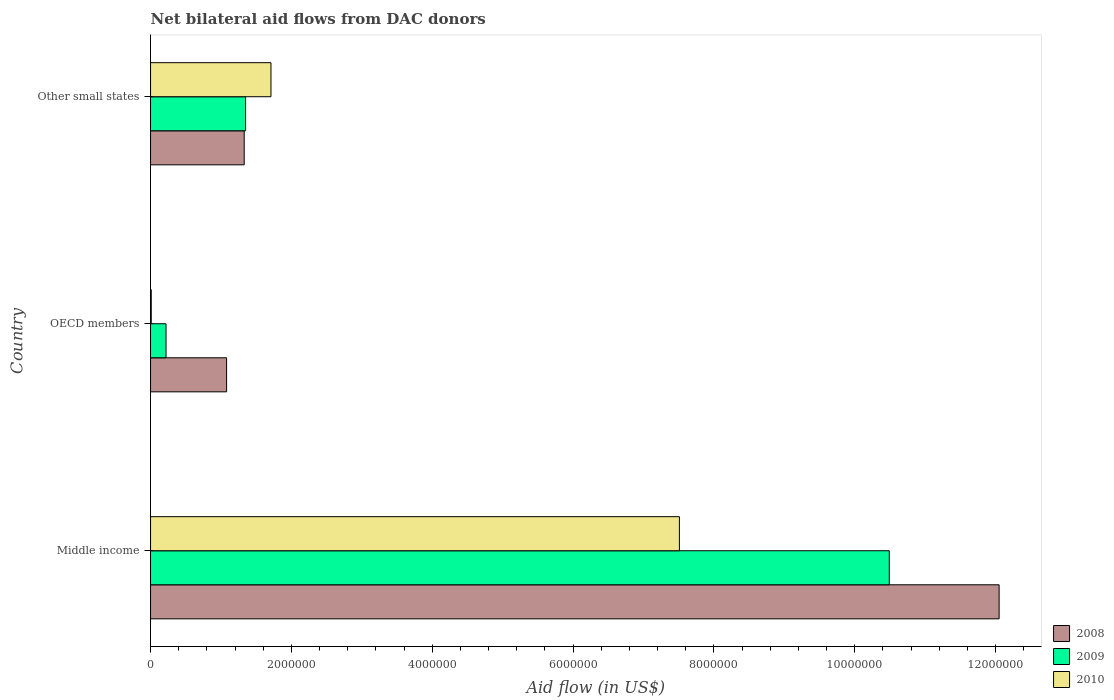How many groups of bars are there?
Provide a succinct answer. 3. Are the number of bars per tick equal to the number of legend labels?
Your response must be concise. Yes. Are the number of bars on each tick of the Y-axis equal?
Offer a terse response. Yes. How many bars are there on the 1st tick from the top?
Your response must be concise. 3. How many bars are there on the 2nd tick from the bottom?
Give a very brief answer. 3. What is the label of the 1st group of bars from the top?
Your response must be concise. Other small states. What is the net bilateral aid flow in 2010 in Other small states?
Your answer should be very brief. 1.71e+06. Across all countries, what is the maximum net bilateral aid flow in 2008?
Give a very brief answer. 1.20e+07. Across all countries, what is the minimum net bilateral aid flow in 2010?
Your response must be concise. 10000. In which country was the net bilateral aid flow in 2008 maximum?
Ensure brevity in your answer.  Middle income. In which country was the net bilateral aid flow in 2008 minimum?
Provide a succinct answer. OECD members. What is the total net bilateral aid flow in 2008 in the graph?
Ensure brevity in your answer.  1.45e+07. What is the difference between the net bilateral aid flow in 2008 in Middle income and that in Other small states?
Provide a short and direct response. 1.07e+07. What is the difference between the net bilateral aid flow in 2008 in Middle income and the net bilateral aid flow in 2010 in Other small states?
Offer a very short reply. 1.03e+07. What is the average net bilateral aid flow in 2009 per country?
Provide a succinct answer. 4.02e+06. What is the difference between the net bilateral aid flow in 2010 and net bilateral aid flow in 2009 in Middle income?
Provide a short and direct response. -2.98e+06. In how many countries, is the net bilateral aid flow in 2008 greater than 3200000 US$?
Offer a very short reply. 1. What is the ratio of the net bilateral aid flow in 2009 in Middle income to that in Other small states?
Offer a very short reply. 7.77. What is the difference between the highest and the second highest net bilateral aid flow in 2009?
Keep it short and to the point. 9.14e+06. What is the difference between the highest and the lowest net bilateral aid flow in 2010?
Offer a terse response. 7.50e+06. In how many countries, is the net bilateral aid flow in 2008 greater than the average net bilateral aid flow in 2008 taken over all countries?
Your response must be concise. 1. Is the sum of the net bilateral aid flow in 2009 in Middle income and OECD members greater than the maximum net bilateral aid flow in 2010 across all countries?
Your answer should be very brief. Yes. Is it the case that in every country, the sum of the net bilateral aid flow in 2010 and net bilateral aid flow in 2009 is greater than the net bilateral aid flow in 2008?
Keep it short and to the point. No. Are all the bars in the graph horizontal?
Give a very brief answer. Yes. How many countries are there in the graph?
Provide a succinct answer. 3. Are the values on the major ticks of X-axis written in scientific E-notation?
Offer a very short reply. No. Does the graph contain any zero values?
Offer a terse response. No. Where does the legend appear in the graph?
Offer a very short reply. Bottom right. What is the title of the graph?
Offer a terse response. Net bilateral aid flows from DAC donors. What is the label or title of the X-axis?
Your answer should be compact. Aid flow (in US$). What is the Aid flow (in US$) in 2008 in Middle income?
Keep it short and to the point. 1.20e+07. What is the Aid flow (in US$) of 2009 in Middle income?
Your answer should be very brief. 1.05e+07. What is the Aid flow (in US$) of 2010 in Middle income?
Provide a short and direct response. 7.51e+06. What is the Aid flow (in US$) of 2008 in OECD members?
Make the answer very short. 1.08e+06. What is the Aid flow (in US$) in 2008 in Other small states?
Your response must be concise. 1.33e+06. What is the Aid flow (in US$) in 2009 in Other small states?
Offer a terse response. 1.35e+06. What is the Aid flow (in US$) in 2010 in Other small states?
Your response must be concise. 1.71e+06. Across all countries, what is the maximum Aid flow (in US$) of 2008?
Provide a short and direct response. 1.20e+07. Across all countries, what is the maximum Aid flow (in US$) of 2009?
Your answer should be compact. 1.05e+07. Across all countries, what is the maximum Aid flow (in US$) in 2010?
Make the answer very short. 7.51e+06. Across all countries, what is the minimum Aid flow (in US$) of 2008?
Offer a terse response. 1.08e+06. Across all countries, what is the minimum Aid flow (in US$) of 2009?
Offer a very short reply. 2.20e+05. What is the total Aid flow (in US$) in 2008 in the graph?
Offer a very short reply. 1.45e+07. What is the total Aid flow (in US$) of 2009 in the graph?
Offer a very short reply. 1.21e+07. What is the total Aid flow (in US$) in 2010 in the graph?
Ensure brevity in your answer.  9.23e+06. What is the difference between the Aid flow (in US$) of 2008 in Middle income and that in OECD members?
Keep it short and to the point. 1.10e+07. What is the difference between the Aid flow (in US$) in 2009 in Middle income and that in OECD members?
Provide a short and direct response. 1.03e+07. What is the difference between the Aid flow (in US$) in 2010 in Middle income and that in OECD members?
Your answer should be very brief. 7.50e+06. What is the difference between the Aid flow (in US$) in 2008 in Middle income and that in Other small states?
Give a very brief answer. 1.07e+07. What is the difference between the Aid flow (in US$) of 2009 in Middle income and that in Other small states?
Your response must be concise. 9.14e+06. What is the difference between the Aid flow (in US$) of 2010 in Middle income and that in Other small states?
Your answer should be very brief. 5.80e+06. What is the difference between the Aid flow (in US$) of 2008 in OECD members and that in Other small states?
Your answer should be compact. -2.50e+05. What is the difference between the Aid flow (in US$) of 2009 in OECD members and that in Other small states?
Your answer should be compact. -1.13e+06. What is the difference between the Aid flow (in US$) of 2010 in OECD members and that in Other small states?
Ensure brevity in your answer.  -1.70e+06. What is the difference between the Aid flow (in US$) in 2008 in Middle income and the Aid flow (in US$) in 2009 in OECD members?
Your answer should be very brief. 1.18e+07. What is the difference between the Aid flow (in US$) in 2008 in Middle income and the Aid flow (in US$) in 2010 in OECD members?
Provide a succinct answer. 1.20e+07. What is the difference between the Aid flow (in US$) in 2009 in Middle income and the Aid flow (in US$) in 2010 in OECD members?
Give a very brief answer. 1.05e+07. What is the difference between the Aid flow (in US$) of 2008 in Middle income and the Aid flow (in US$) of 2009 in Other small states?
Keep it short and to the point. 1.07e+07. What is the difference between the Aid flow (in US$) of 2008 in Middle income and the Aid flow (in US$) of 2010 in Other small states?
Provide a succinct answer. 1.03e+07. What is the difference between the Aid flow (in US$) of 2009 in Middle income and the Aid flow (in US$) of 2010 in Other small states?
Your answer should be compact. 8.78e+06. What is the difference between the Aid flow (in US$) of 2008 in OECD members and the Aid flow (in US$) of 2009 in Other small states?
Give a very brief answer. -2.70e+05. What is the difference between the Aid flow (in US$) in 2008 in OECD members and the Aid flow (in US$) in 2010 in Other small states?
Your response must be concise. -6.30e+05. What is the difference between the Aid flow (in US$) of 2009 in OECD members and the Aid flow (in US$) of 2010 in Other small states?
Your answer should be compact. -1.49e+06. What is the average Aid flow (in US$) of 2008 per country?
Provide a short and direct response. 4.82e+06. What is the average Aid flow (in US$) of 2009 per country?
Ensure brevity in your answer.  4.02e+06. What is the average Aid flow (in US$) of 2010 per country?
Your answer should be compact. 3.08e+06. What is the difference between the Aid flow (in US$) of 2008 and Aid flow (in US$) of 2009 in Middle income?
Give a very brief answer. 1.56e+06. What is the difference between the Aid flow (in US$) in 2008 and Aid flow (in US$) in 2010 in Middle income?
Ensure brevity in your answer.  4.54e+06. What is the difference between the Aid flow (in US$) of 2009 and Aid flow (in US$) of 2010 in Middle income?
Your response must be concise. 2.98e+06. What is the difference between the Aid flow (in US$) in 2008 and Aid flow (in US$) in 2009 in OECD members?
Offer a terse response. 8.60e+05. What is the difference between the Aid flow (in US$) of 2008 and Aid flow (in US$) of 2010 in OECD members?
Your response must be concise. 1.07e+06. What is the difference between the Aid flow (in US$) of 2008 and Aid flow (in US$) of 2010 in Other small states?
Give a very brief answer. -3.80e+05. What is the difference between the Aid flow (in US$) of 2009 and Aid flow (in US$) of 2010 in Other small states?
Keep it short and to the point. -3.60e+05. What is the ratio of the Aid flow (in US$) in 2008 in Middle income to that in OECD members?
Your answer should be compact. 11.16. What is the ratio of the Aid flow (in US$) of 2009 in Middle income to that in OECD members?
Give a very brief answer. 47.68. What is the ratio of the Aid flow (in US$) in 2010 in Middle income to that in OECD members?
Make the answer very short. 751. What is the ratio of the Aid flow (in US$) in 2008 in Middle income to that in Other small states?
Your response must be concise. 9.06. What is the ratio of the Aid flow (in US$) of 2009 in Middle income to that in Other small states?
Your answer should be very brief. 7.77. What is the ratio of the Aid flow (in US$) of 2010 in Middle income to that in Other small states?
Keep it short and to the point. 4.39. What is the ratio of the Aid flow (in US$) of 2008 in OECD members to that in Other small states?
Ensure brevity in your answer.  0.81. What is the ratio of the Aid flow (in US$) in 2009 in OECD members to that in Other small states?
Ensure brevity in your answer.  0.16. What is the ratio of the Aid flow (in US$) in 2010 in OECD members to that in Other small states?
Your answer should be compact. 0.01. What is the difference between the highest and the second highest Aid flow (in US$) in 2008?
Give a very brief answer. 1.07e+07. What is the difference between the highest and the second highest Aid flow (in US$) in 2009?
Give a very brief answer. 9.14e+06. What is the difference between the highest and the second highest Aid flow (in US$) in 2010?
Offer a very short reply. 5.80e+06. What is the difference between the highest and the lowest Aid flow (in US$) of 2008?
Your answer should be compact. 1.10e+07. What is the difference between the highest and the lowest Aid flow (in US$) of 2009?
Make the answer very short. 1.03e+07. What is the difference between the highest and the lowest Aid flow (in US$) in 2010?
Offer a very short reply. 7.50e+06. 